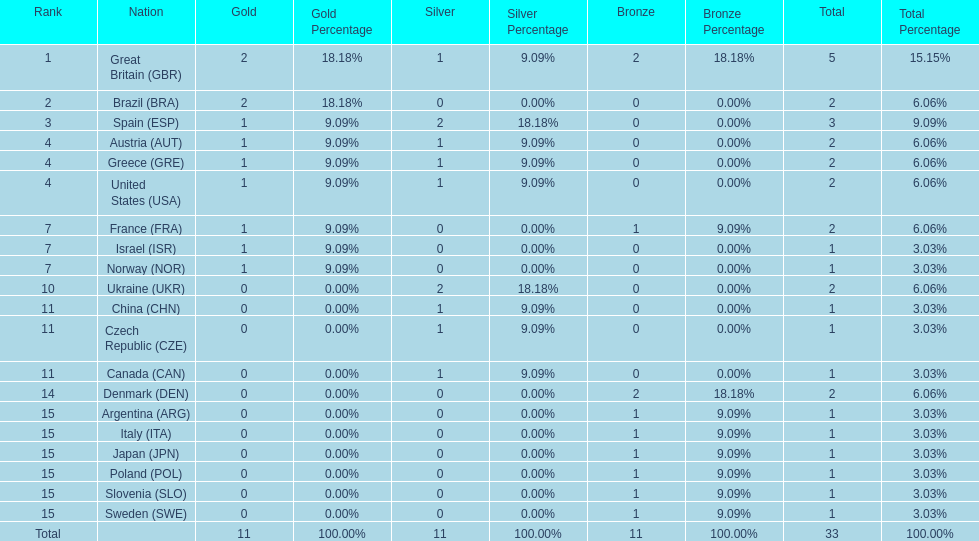What nation was next to great britain in total medal count? Spain. 